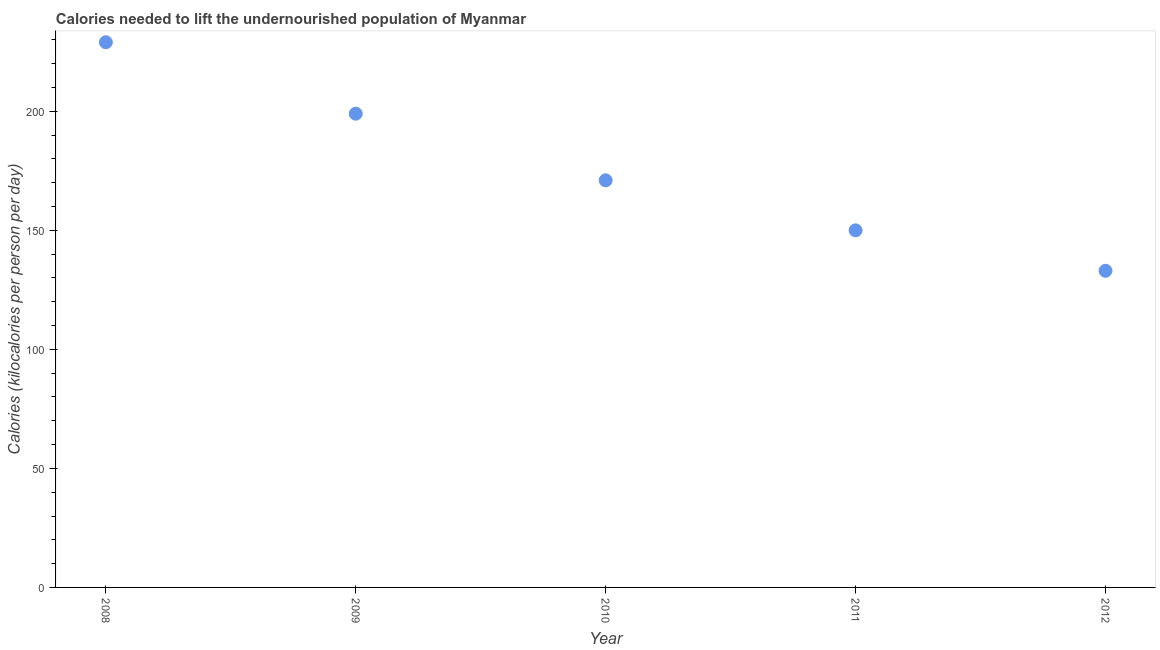What is the depth of food deficit in 2011?
Your answer should be compact. 150. Across all years, what is the maximum depth of food deficit?
Keep it short and to the point. 229. Across all years, what is the minimum depth of food deficit?
Ensure brevity in your answer.  133. In which year was the depth of food deficit minimum?
Offer a very short reply. 2012. What is the sum of the depth of food deficit?
Provide a succinct answer. 882. What is the difference between the depth of food deficit in 2011 and 2012?
Your answer should be compact. 17. What is the average depth of food deficit per year?
Offer a terse response. 176.4. What is the median depth of food deficit?
Provide a short and direct response. 171. In how many years, is the depth of food deficit greater than 200 kilocalories?
Offer a terse response. 1. What is the ratio of the depth of food deficit in 2008 to that in 2009?
Your answer should be very brief. 1.15. Is the sum of the depth of food deficit in 2008 and 2011 greater than the maximum depth of food deficit across all years?
Your answer should be compact. Yes. What is the difference between the highest and the lowest depth of food deficit?
Your response must be concise. 96. How many years are there in the graph?
Make the answer very short. 5. What is the title of the graph?
Ensure brevity in your answer.  Calories needed to lift the undernourished population of Myanmar. What is the label or title of the X-axis?
Provide a succinct answer. Year. What is the label or title of the Y-axis?
Make the answer very short. Calories (kilocalories per person per day). What is the Calories (kilocalories per person per day) in 2008?
Your answer should be very brief. 229. What is the Calories (kilocalories per person per day) in 2009?
Give a very brief answer. 199. What is the Calories (kilocalories per person per day) in 2010?
Your response must be concise. 171. What is the Calories (kilocalories per person per day) in 2011?
Ensure brevity in your answer.  150. What is the Calories (kilocalories per person per day) in 2012?
Give a very brief answer. 133. What is the difference between the Calories (kilocalories per person per day) in 2008 and 2011?
Provide a succinct answer. 79. What is the difference between the Calories (kilocalories per person per day) in 2008 and 2012?
Your answer should be compact. 96. What is the difference between the Calories (kilocalories per person per day) in 2009 and 2010?
Your answer should be compact. 28. What is the difference between the Calories (kilocalories per person per day) in 2009 and 2011?
Offer a very short reply. 49. What is the ratio of the Calories (kilocalories per person per day) in 2008 to that in 2009?
Offer a very short reply. 1.15. What is the ratio of the Calories (kilocalories per person per day) in 2008 to that in 2010?
Your answer should be very brief. 1.34. What is the ratio of the Calories (kilocalories per person per day) in 2008 to that in 2011?
Offer a terse response. 1.53. What is the ratio of the Calories (kilocalories per person per day) in 2008 to that in 2012?
Your answer should be very brief. 1.72. What is the ratio of the Calories (kilocalories per person per day) in 2009 to that in 2010?
Offer a terse response. 1.16. What is the ratio of the Calories (kilocalories per person per day) in 2009 to that in 2011?
Offer a terse response. 1.33. What is the ratio of the Calories (kilocalories per person per day) in 2009 to that in 2012?
Provide a short and direct response. 1.5. What is the ratio of the Calories (kilocalories per person per day) in 2010 to that in 2011?
Offer a terse response. 1.14. What is the ratio of the Calories (kilocalories per person per day) in 2010 to that in 2012?
Keep it short and to the point. 1.29. What is the ratio of the Calories (kilocalories per person per day) in 2011 to that in 2012?
Make the answer very short. 1.13. 